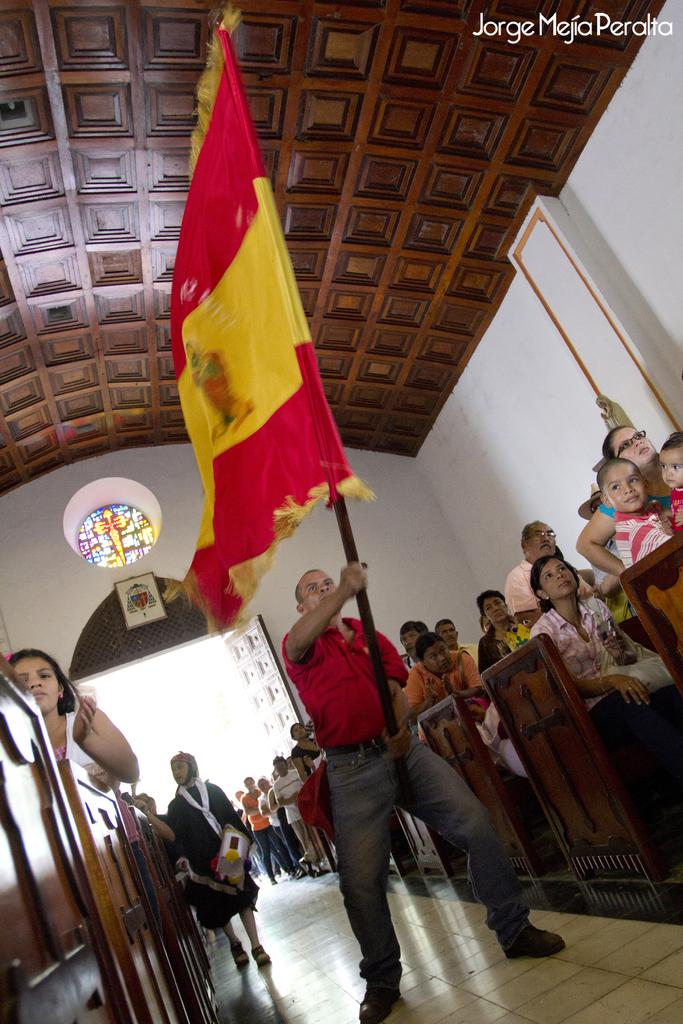What is the main subject of the image? There is a person standing in the middle of the image. What is the person holding in the image? The person is holding a flag. Can you describe the people behind the person holding the flag? There are people standing and sitting behind the person holding the flag. What can be seen at the top of the image? There is a wall and a ceiling visible at the top of the image. What type of agreement was reached during the meeting depicted in the image? There is no meeting depicted in the image, and therefore no agreement can be discussed. What is the profit margin of the company represented in the image? There is no company or profit margin mentioned in the image. 